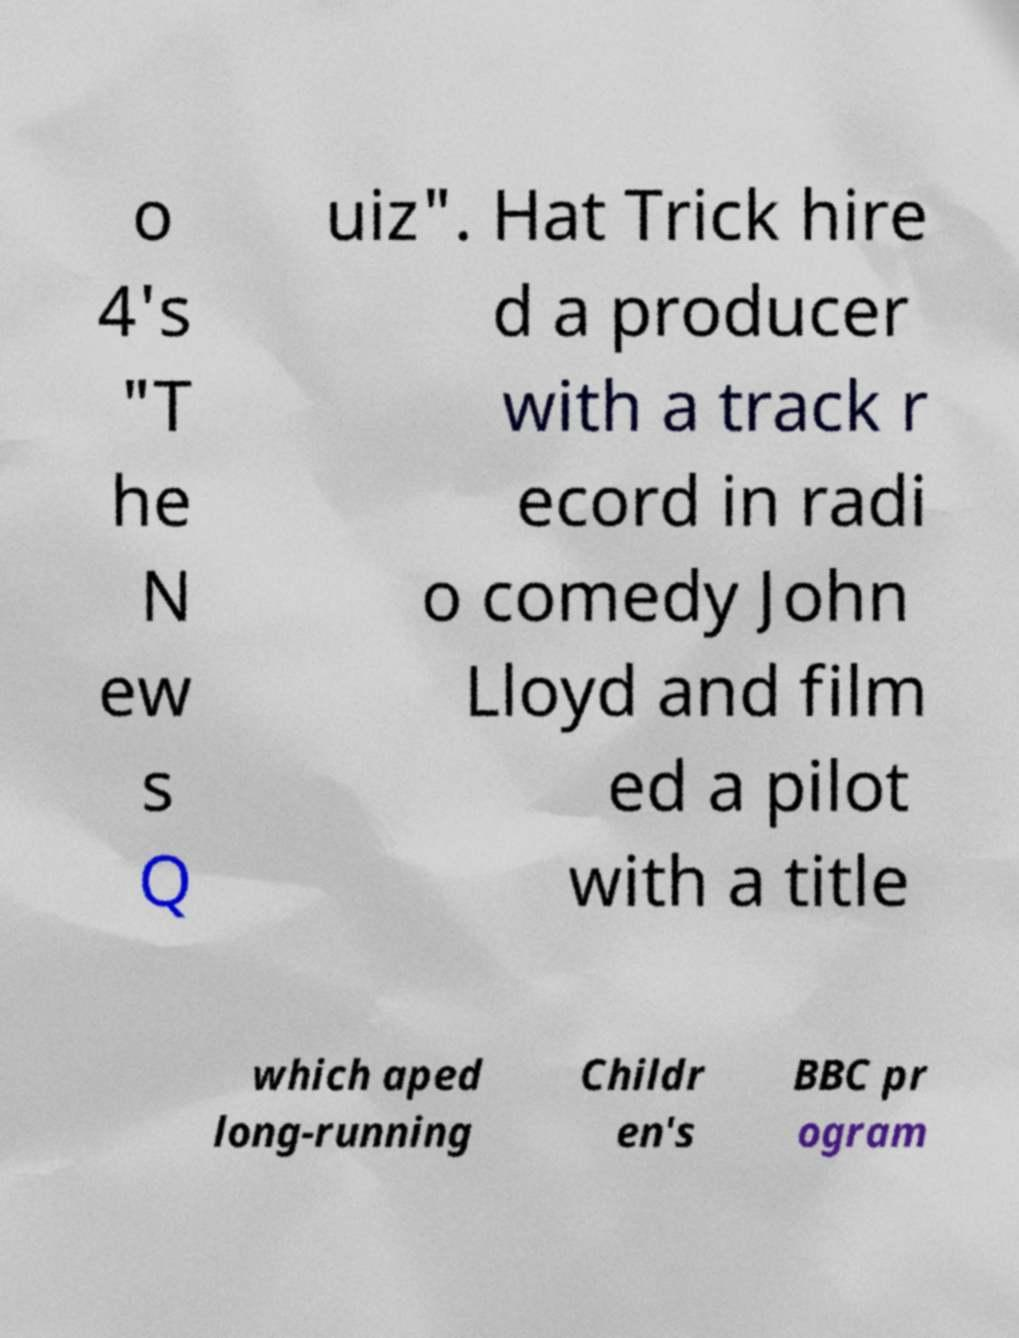Please read and relay the text visible in this image. What does it say? o 4's "T he N ew s Q uiz". Hat Trick hire d a producer with a track r ecord in radi o comedy John Lloyd and film ed a pilot with a title which aped long-running Childr en's BBC pr ogram 